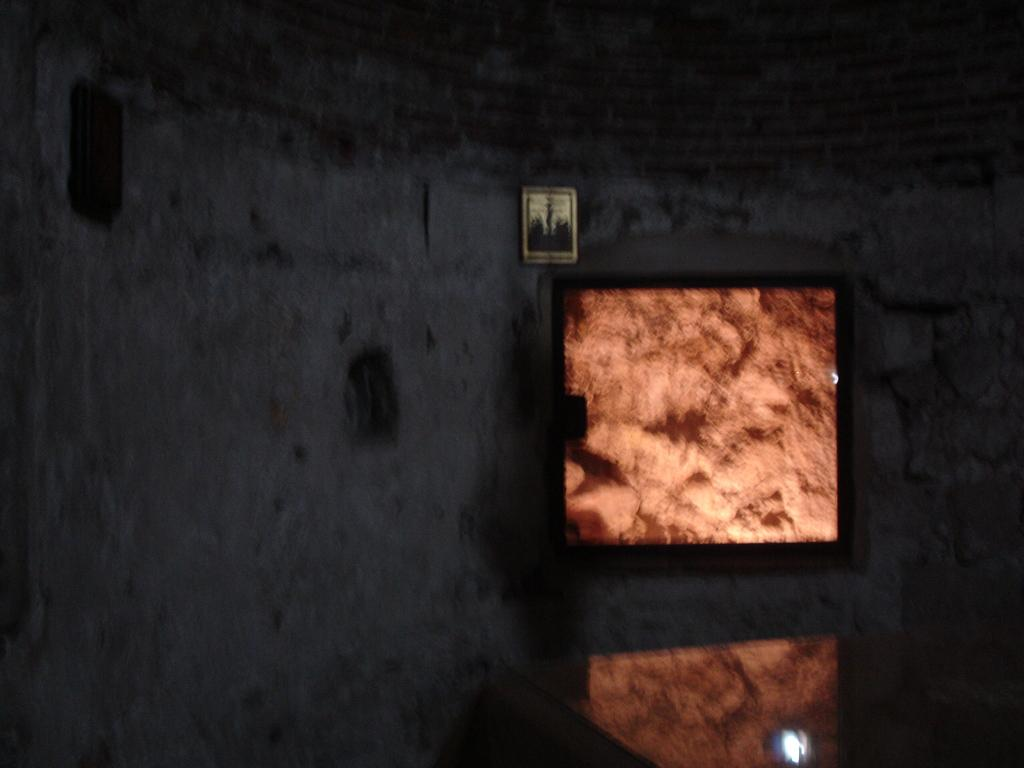What is on the wall in the image? There is a frame on the wall in the image. Can you describe the objects in the image? Unfortunately, the objects in the image are blurry, so their specific details are unclear. What type of leaf is visible in the image? There is no leaf present in the image; it only features a frame on the wall and blurry objects. 